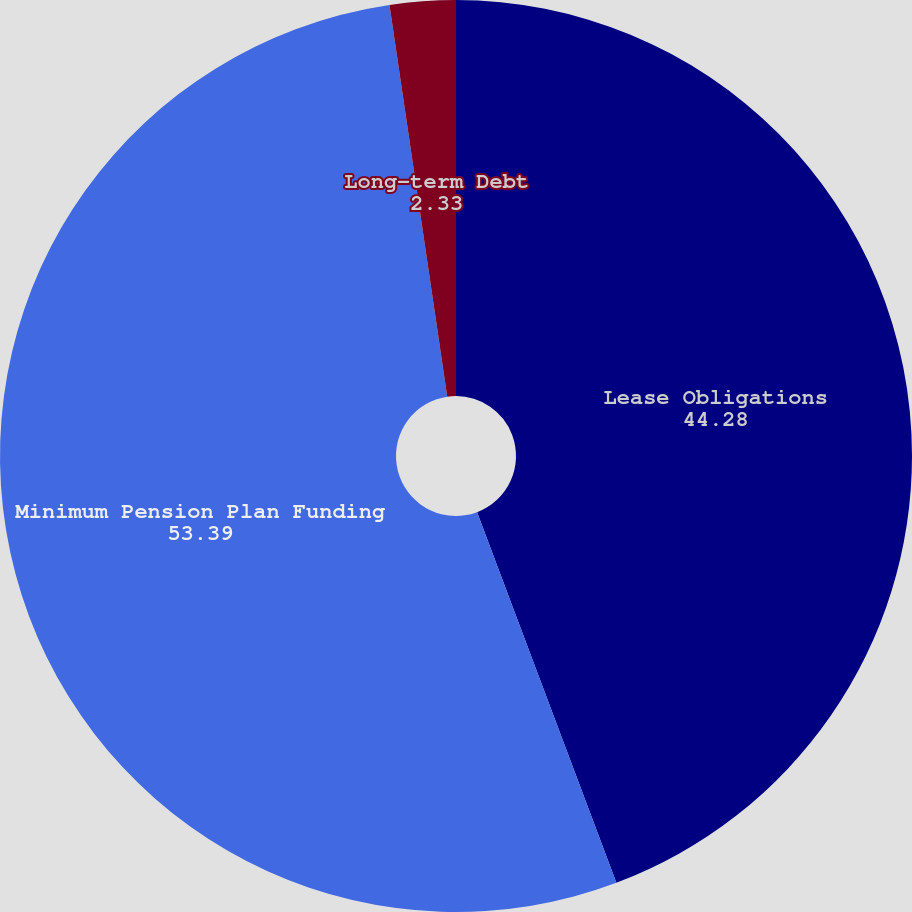Convert chart to OTSL. <chart><loc_0><loc_0><loc_500><loc_500><pie_chart><fcel>Lease Obligations<fcel>Minimum Pension Plan Funding<fcel>Long-term Debt<nl><fcel>44.28%<fcel>53.39%<fcel>2.33%<nl></chart> 